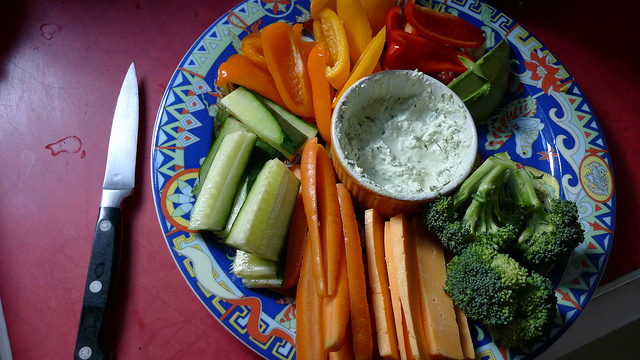How many carrots are in the photo? In the photo, there is an array of vegetables prepared for dipping, but there are no carrots present. The brightly colored vegetables include sliced cucumber, bell peppers, and broccoli, along with a savory dip in the center. 